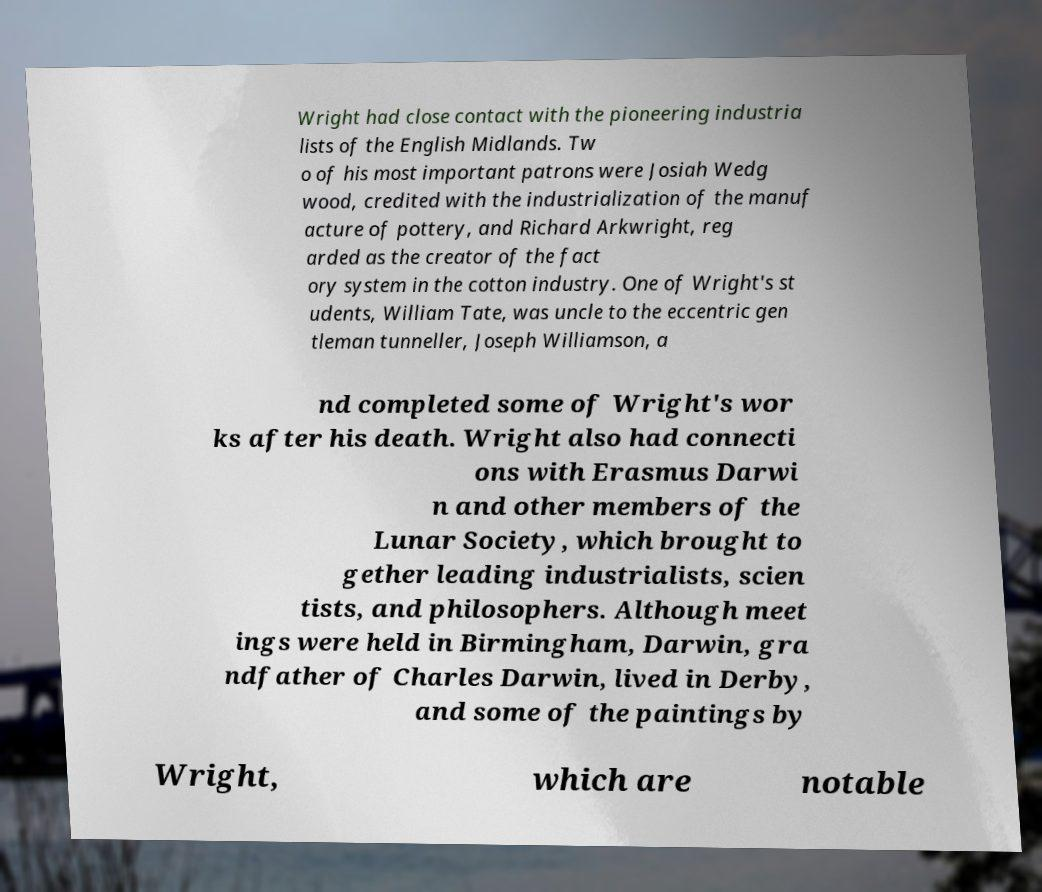For documentation purposes, I need the text within this image transcribed. Could you provide that? Wright had close contact with the pioneering industria lists of the English Midlands. Tw o of his most important patrons were Josiah Wedg wood, credited with the industrialization of the manuf acture of pottery, and Richard Arkwright, reg arded as the creator of the fact ory system in the cotton industry. One of Wright's st udents, William Tate, was uncle to the eccentric gen tleman tunneller, Joseph Williamson, a nd completed some of Wright's wor ks after his death. Wright also had connecti ons with Erasmus Darwi n and other members of the Lunar Society, which brought to gether leading industrialists, scien tists, and philosophers. Although meet ings were held in Birmingham, Darwin, gra ndfather of Charles Darwin, lived in Derby, and some of the paintings by Wright, which are notable 